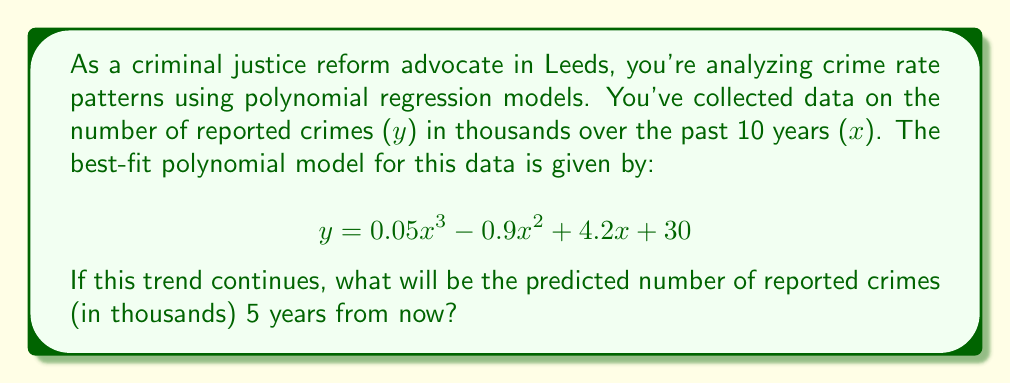Show me your answer to this math problem. To solve this problem, we need to follow these steps:

1. Understand the given polynomial regression model:
   $$y = 0.05x^3 - 0.9x^2 + 4.2x + 30$$
   where y is the number of reported crimes in thousands, and x is the number of years.

2. Determine the value of x for 5 years from now:
   - The data covers the past 10 years, so the current year is x = 10
   - 5 years from now would be x = 15

3. Substitute x = 15 into the polynomial equation:
   $$y = 0.05(15)^3 - 0.9(15)^2 + 4.2(15) + 30$$

4. Calculate each term:
   - $0.05(15)^3 = 0.05 * 3375 = 168.75$
   - $-0.9(15)^2 = -0.9 * 225 = -202.5$
   - $4.2(15) = 63$
   - $30$ remains as is

5. Sum up all the terms:
   $$y = 168.75 - 202.5 + 63 + 30 = 59.25$$

Therefore, the predicted number of reported crimes 5 years from now is 59.25 thousand.
Answer: 59.25 thousand 